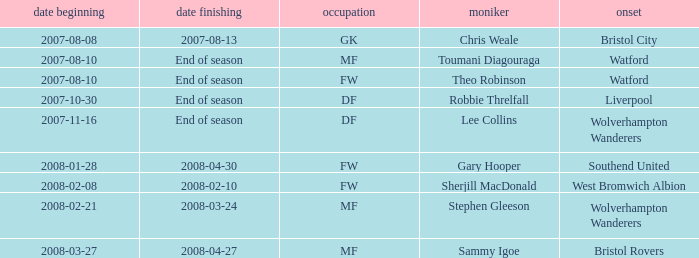What was the Date From for Theo Robinson, who was with the team until the end of season? 2007-08-10. 